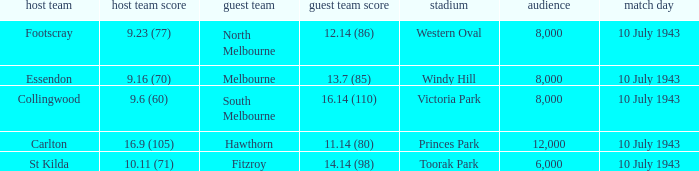When the Away team scored 14.14 (98), which Venue did the game take place? Toorak Park. 